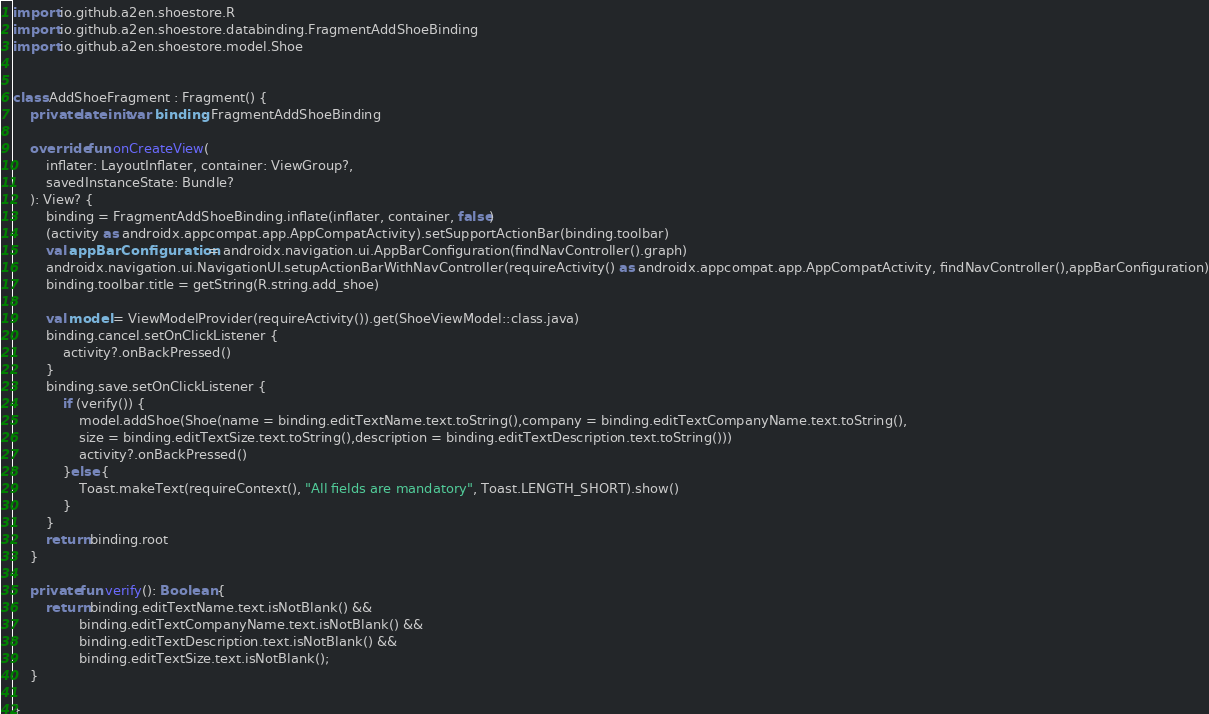Convert code to text. <code><loc_0><loc_0><loc_500><loc_500><_Kotlin_>import io.github.a2en.shoestore.R
import io.github.a2en.shoestore.databinding.FragmentAddShoeBinding
import io.github.a2en.shoestore.model.Shoe


class AddShoeFragment : Fragment() {
    private lateinit var binding: FragmentAddShoeBinding

    override fun onCreateView(
        inflater: LayoutInflater, container: ViewGroup?,
        savedInstanceState: Bundle?
    ): View? {
        binding = FragmentAddShoeBinding.inflate(inflater, container, false)
        (activity as androidx.appcompat.app.AppCompatActivity).setSupportActionBar(binding.toolbar)
        val appBarConfiguration = androidx.navigation.ui.AppBarConfiguration(findNavController().graph)
        androidx.navigation.ui.NavigationUI.setupActionBarWithNavController(requireActivity() as androidx.appcompat.app.AppCompatActivity, findNavController(),appBarConfiguration)
        binding.toolbar.title = getString(R.string.add_shoe)

        val model = ViewModelProvider(requireActivity()).get(ShoeViewModel::class.java)
        binding.cancel.setOnClickListener {
            activity?.onBackPressed()
        }
        binding.save.setOnClickListener {
            if (verify()) {
                model.addShoe(Shoe(name = binding.editTextName.text.toString(),company = binding.editTextCompanyName.text.toString(),
                size = binding.editTextSize.text.toString(),description = binding.editTextDescription.text.toString()))
                activity?.onBackPressed()
            }else {
                Toast.makeText(requireContext(), "All fields are mandatory", Toast.LENGTH_SHORT).show()
            }
        }
        return binding.root
    }

    private fun verify(): Boolean {
        return binding.editTextName.text.isNotBlank() &&
                binding.editTextCompanyName.text.isNotBlank() &&
                binding.editTextDescription.text.isNotBlank() &&
                binding.editTextSize.text.isNotBlank();
    }

}</code> 